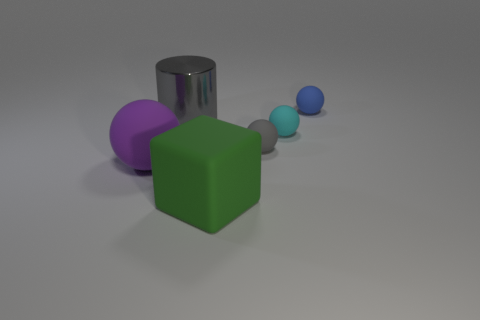What is the shape of the small thing that is the same color as the big metal cylinder?
Keep it short and to the point. Sphere. There is a thing that is the same color as the cylinder; what size is it?
Give a very brief answer. Small. There is a rubber object that is in front of the large ball behind the big green rubber block that is to the right of the metal cylinder; what is its shape?
Make the answer very short. Cube. Do the cylinder and the cyan rubber sphere have the same size?
Ensure brevity in your answer.  No. How many objects are large gray rubber spheres or rubber spheres to the left of the green thing?
Offer a terse response. 1. What number of things are either big rubber things to the right of the large shiny cylinder or tiny balls behind the tiny cyan matte object?
Keep it short and to the point. 2. Are there any purple rubber things right of the tiny gray ball?
Offer a very short reply. No. There is a matte sphere that is in front of the gray object right of the gray thing that is left of the large green object; what color is it?
Make the answer very short. Purple. Do the big gray thing and the gray rubber thing have the same shape?
Your answer should be compact. No. The large block that is the same material as the large purple sphere is what color?
Provide a short and direct response. Green. 